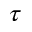<formula> <loc_0><loc_0><loc_500><loc_500>\tau</formula> 